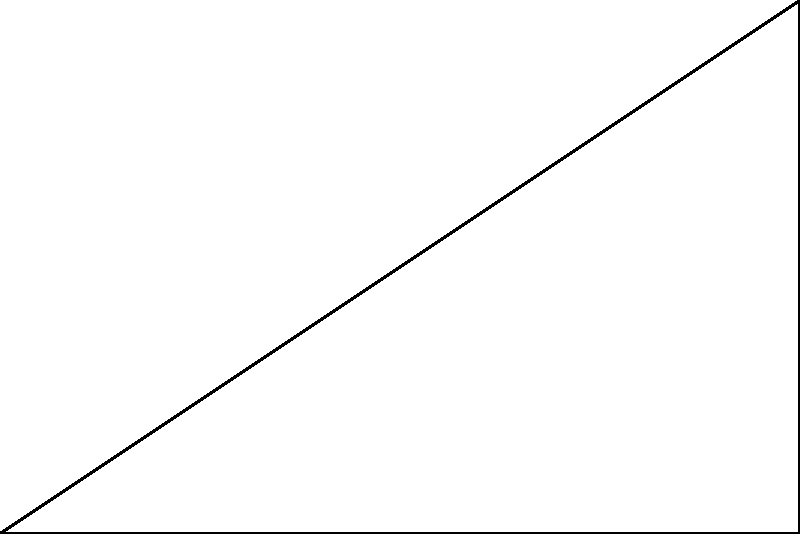As a runner striving for optimal performance, you're analyzing your stride angle. In the diagram, OAB represents your leg during a stride, where OA is the ground, and AB is your leg. If OA = 90 cm and AB = 100 cm, what is the optimal stride angle $\theta$ (in degrees) for maximizing your running efficiency? To find the optimal stride angle $\theta$, we'll use the following steps:

1) In the right triangle OAB, we can use the cosine function to relate the angle $\theta$ to the given sides:

   $\cos(\theta) = \frac{\text{adjacent}}{\text{hypotenuse}} = \frac{OA}{AB}$

2) Substitute the known values:
   $\cos(\theta) = \frac{90 \text{ cm}}{100 \text{ cm}} = 0.9$

3) To find $\theta$, we need to take the inverse cosine (arccos) of both sides:
   $\theta = \arccos(0.9)$

4) Using a calculator or computer:
   $\theta \approx 25.84^\circ$

5) Research in sports biomechanics suggests that the optimal stride angle for running efficiency is typically around 25-30 degrees. Our calculated angle falls within this range.

Therefore, the optimal stride angle $\theta$ for maximizing running efficiency is approximately 25.84°.
Answer: $25.84^\circ$ 